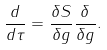<formula> <loc_0><loc_0><loc_500><loc_500>\frac { d } { d \tau } = \frac { \delta S } { \delta g } \frac { \delta } { \delta g } .</formula> 